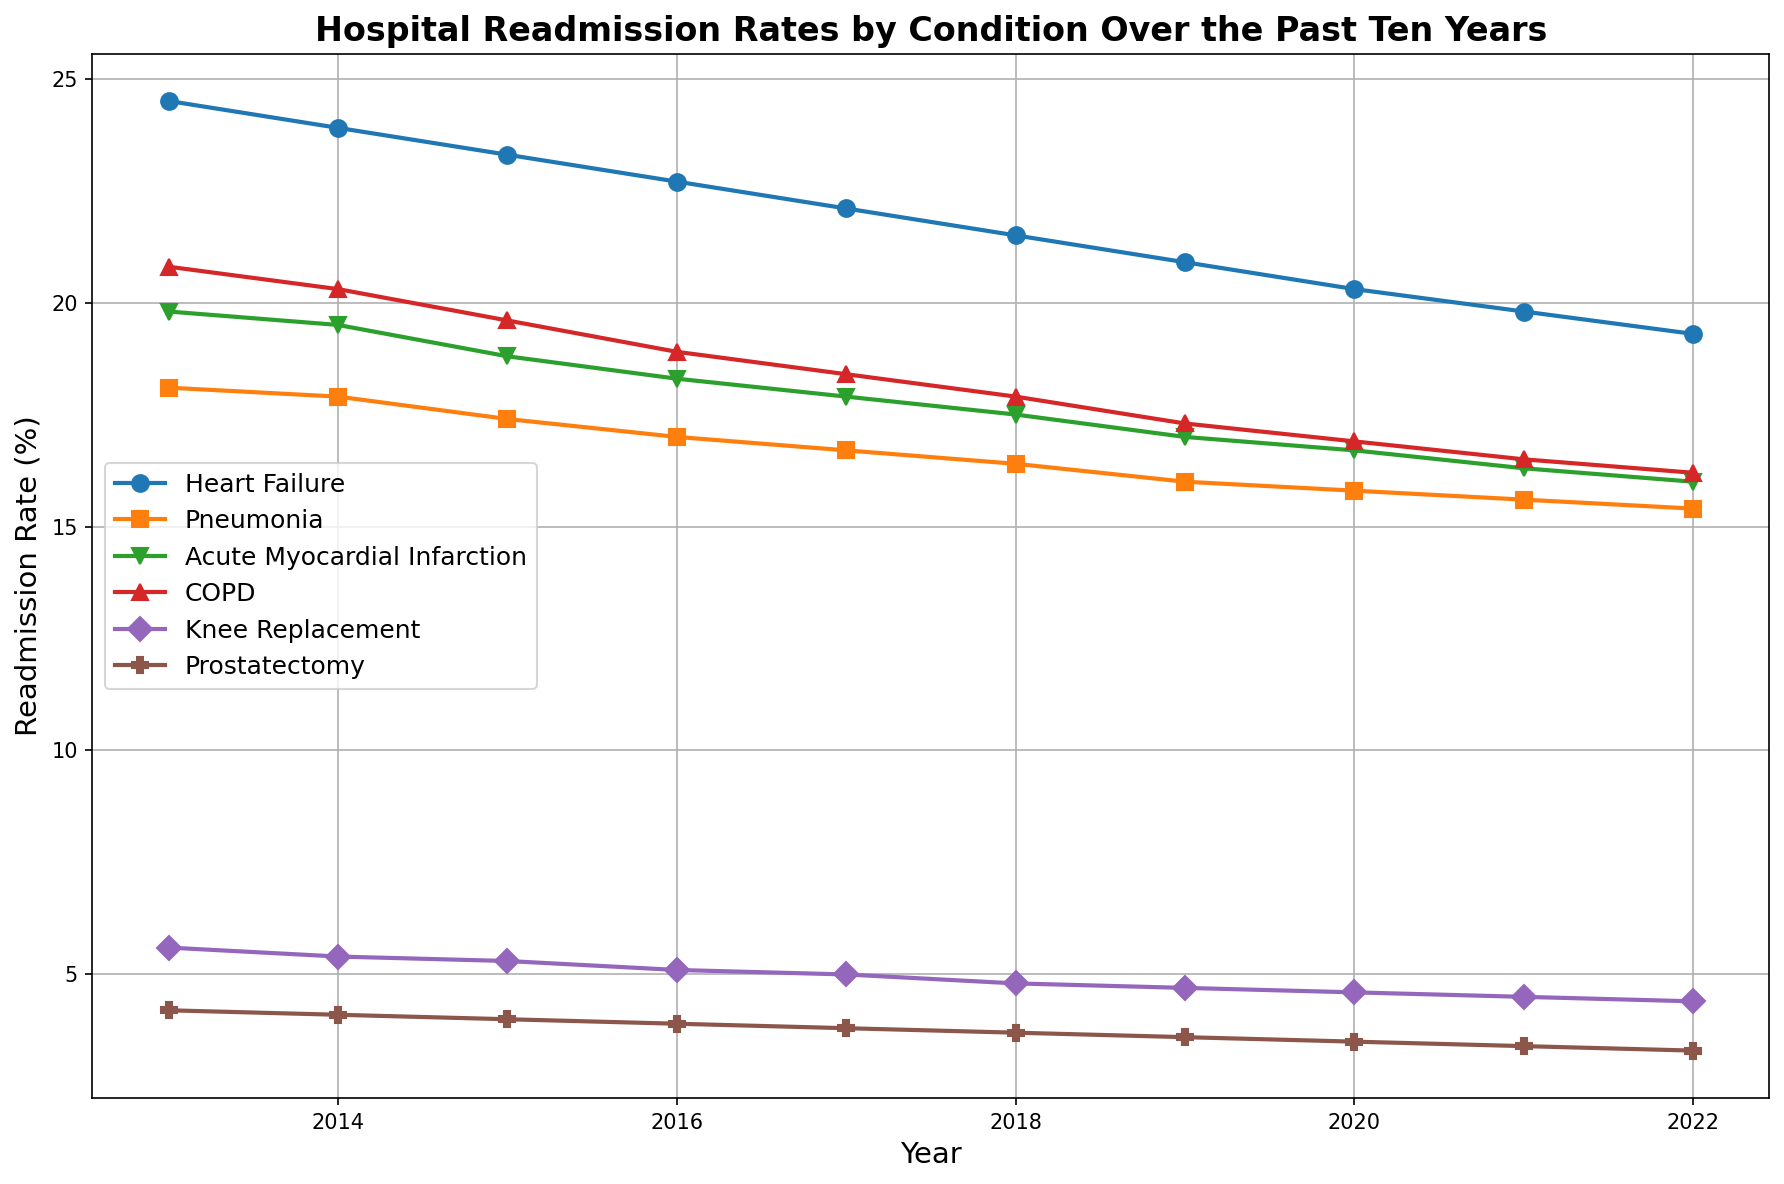What is the overall trend in readmission rates for Heart Failure from 2013 to 2022? To determine the trend in readmission rates for Heart Failure, observe how the line representing Heart Failure changes over the years. It shows a consistent decline from 24.5% in 2013 to 19.3% in 2022.
Answer: Declining Between Pneumonia and Acute Myocardial Infarction, which condition had a higher readmission rate in 2018? Refer to the points on the lines corresponding to the year 2018. Pneumonia's readmission rate is 16.4% and Acute Myocardial Infarction's is 17.5%.
Answer: Acute Myocardial Infarction Which condition shows the smallest decrease in readmission rates over the decade? Examine the initial and final readmission rates for each condition and calculate the differences: Heart Failure (24.5%-19.3%), Pneumonia (18.1%-15.4%), Acute Myocardial Infarction (19.8%-16.0%), COPD (20.8%-16.2%), Knee Replacement (5.6%-4.4%), Prostatectomy (4.2%-3.3%). The smallest difference, thus the smallest decrease, is in Prostatectomy (4.2%-3.3% = 0.9%).
Answer: Prostatectomy What is the difference in readmission rates for COPD between 2015 and 2020? Subtract the 2020 readmission rate for COPD from the 2015 rate: 19.6% - 16.9% = 2.7%.
Answer: 2.7% How does the 2022 readmission rate for Knee Replacement compare to that of Prostatectomy in 2020? Refer to the points on the lines corresponding to these conditions and years. Knee Replacement in 2022 is 4.4%, Prostatectomy in 2020 is 3.5%. Comparing these we see that 4.4% (Knee Replacement) is higher than 3.5% (Prostatectomy).
Answer: Higher Which year shows the steepest decline for Heart Failure readmission rates? Observe the distances between consecutive points for Heart Failure. The steepest decline is between 2015 and 2016, where it drops from 23.3% to 22.7% – a 0.6% decrease.
Answer: 2015 to 2016 Considering all conditions, which had the lowest readmission rate in 2017? Compare the points for all conditions in 2017. The smallest value is for Prostatectomy at 3.8%.
Answer: Prostatectomy What is the average readmission rate for Acute Myocardial Infarction over the ten years? Sum all the yearly values and divide by the number of years (10): (19.8 + 19.5 + 18.8 + 18.3 + 17.9 + 17.5 + 17.0 + 16.7 + 16.3 + 16.0) / 10 = 17.78%.
Answer: 17.78% How much did the readmission rate for Pneumonia change from 2014 to 2022? Subtract the 2022 rate from the 2014 rate for Pneumonia: 17.9% - 15.4% = 2.5%.
Answer: 2.5% In which year did readmission rates for Knee Replacement drop below 5% for the first time? Identify the year when the readmission rates for Knee Replacement first fall below 5%. It is in 2017 when the rate is 5.0%.
Answer: 2017 